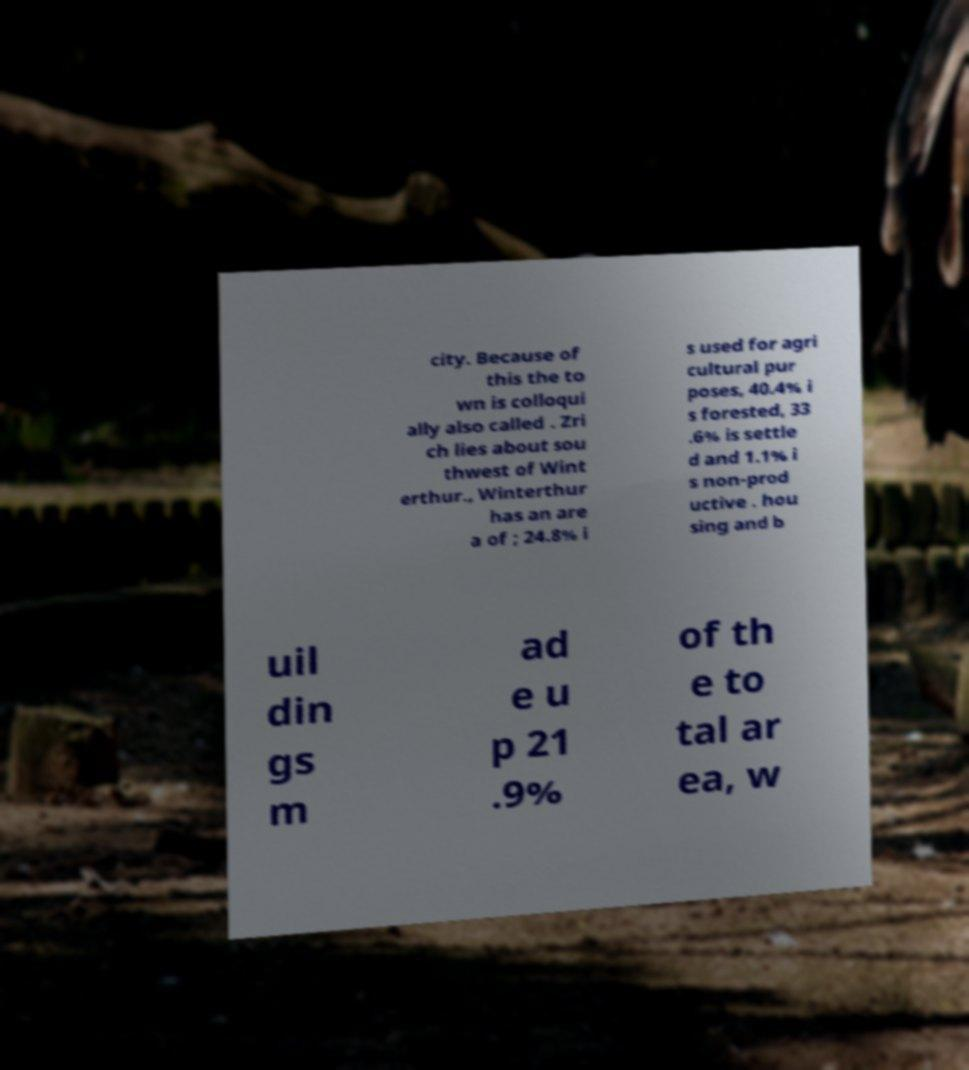What messages or text are displayed in this image? I need them in a readable, typed format. city. Because of this the to wn is colloqui ally also called . Zri ch lies about sou thwest of Wint erthur., Winterthur has an are a of ; 24.8% i s used for agri cultural pur poses, 40.4% i s forested, 33 .6% is settle d and 1.1% i s non-prod uctive . hou sing and b uil din gs m ad e u p 21 .9% of th e to tal ar ea, w 